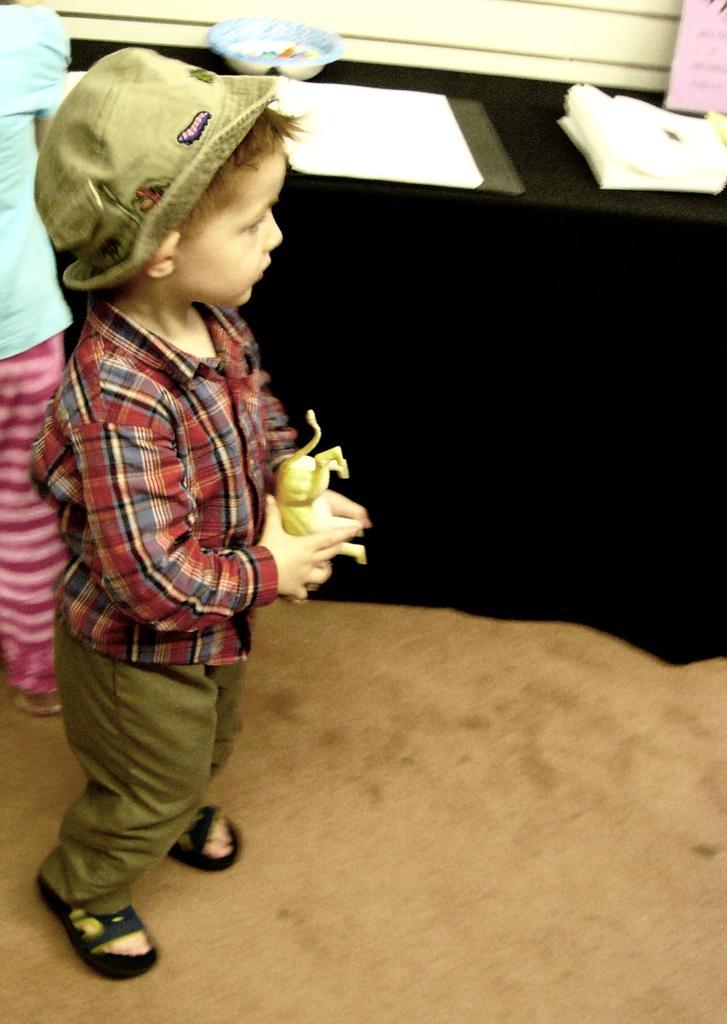Describe this image in one or two sentences. In the image we can see in front there is a kid standing and he is holding a toy in his hand. He is wearing a cap and there are papers on the table. Beside there is another kid who is standing. 